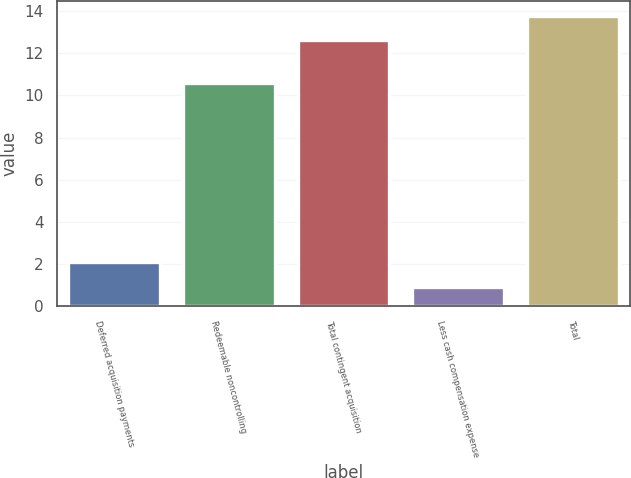Convert chart. <chart><loc_0><loc_0><loc_500><loc_500><bar_chart><fcel>Deferred acquisition payments<fcel>Redeemable noncontrolling<fcel>Total contingent acquisition<fcel>Less cash compensation expense<fcel>Total<nl><fcel>2.08<fcel>10.6<fcel>12.6<fcel>0.91<fcel>13.77<nl></chart> 